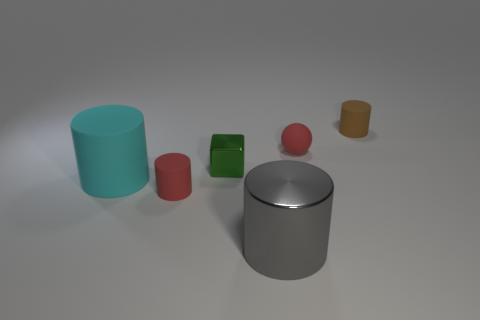The tiny cylinder that is in front of the small thing behind the small red sphere that is behind the big metallic object is made of what material?
Offer a very short reply. Rubber. The cyan thing that is the same material as the tiny brown cylinder is what size?
Offer a very short reply. Large. What color is the object that is in front of the tiny cylinder that is left of the tiny brown thing?
Your answer should be compact. Gray. How many small green things are made of the same material as the gray object?
Provide a succinct answer. 1. How many rubber things are red things or big gray cylinders?
Give a very brief answer. 2. There is a block that is the same size as the red cylinder; what material is it?
Your answer should be compact. Metal. Is there a object made of the same material as the red sphere?
Provide a short and direct response. Yes. What shape is the red thing that is right of the red rubber object left of the gray metal thing on the right side of the small green thing?
Keep it short and to the point. Sphere. There is a red matte sphere; is its size the same as the red rubber object to the left of the metal cylinder?
Provide a succinct answer. Yes. The rubber object that is behind the cyan cylinder and in front of the brown cylinder has what shape?
Offer a very short reply. Sphere. 